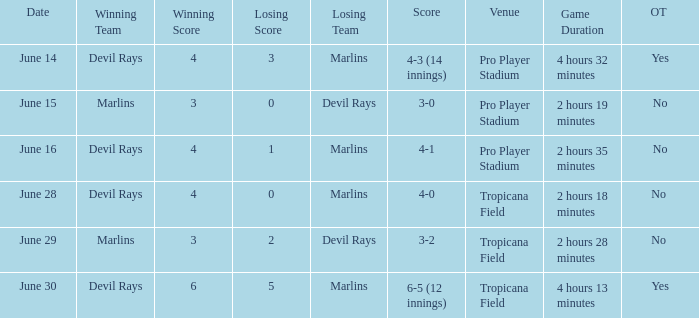What was the score on june 16? 4-1. 